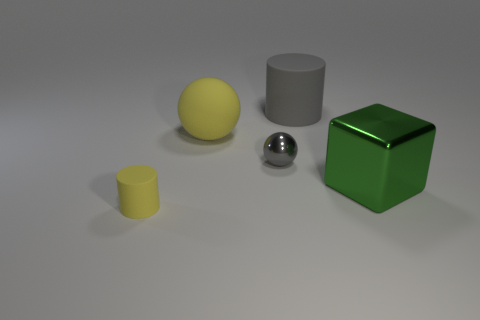Is there a small gray metal thing of the same shape as the large yellow matte thing?
Provide a short and direct response. Yes. There is a small object that is in front of the green object; is its shape the same as the big gray rubber object?
Keep it short and to the point. Yes. What number of objects are on the left side of the small shiny sphere and to the right of the gray cylinder?
Keep it short and to the point. 0. There is a big matte object that is to the right of the gray sphere; what shape is it?
Provide a succinct answer. Cylinder. How many large cubes are made of the same material as the big yellow ball?
Your answer should be very brief. 0. There is a small gray object; is its shape the same as the yellow matte object behind the yellow rubber cylinder?
Your response must be concise. Yes. Are there any small gray objects that are in front of the big thing left of the matte cylinder that is behind the yellow cylinder?
Your answer should be very brief. Yes. How big is the rubber cylinder that is behind the yellow rubber sphere?
Give a very brief answer. Large. There is a yellow object that is the same size as the green metallic block; what is its material?
Provide a short and direct response. Rubber. Is the shape of the gray matte object the same as the tiny rubber object?
Your response must be concise. Yes. 